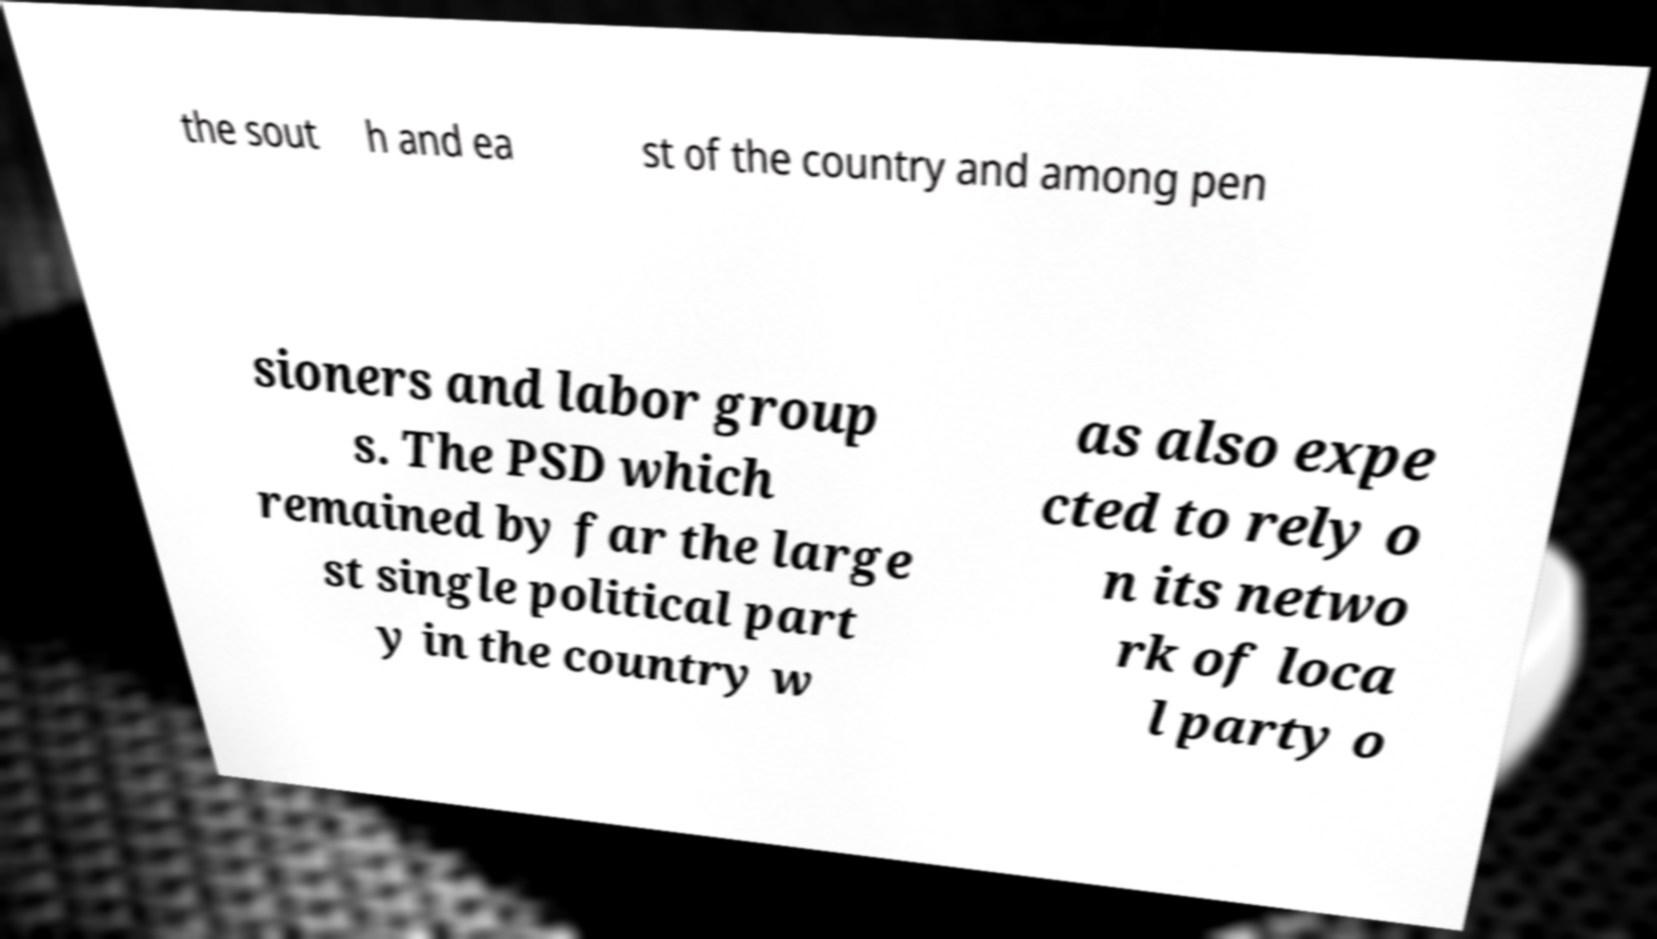For documentation purposes, I need the text within this image transcribed. Could you provide that? the sout h and ea st of the country and among pen sioners and labor group s. The PSD which remained by far the large st single political part y in the country w as also expe cted to rely o n its netwo rk of loca l party o 